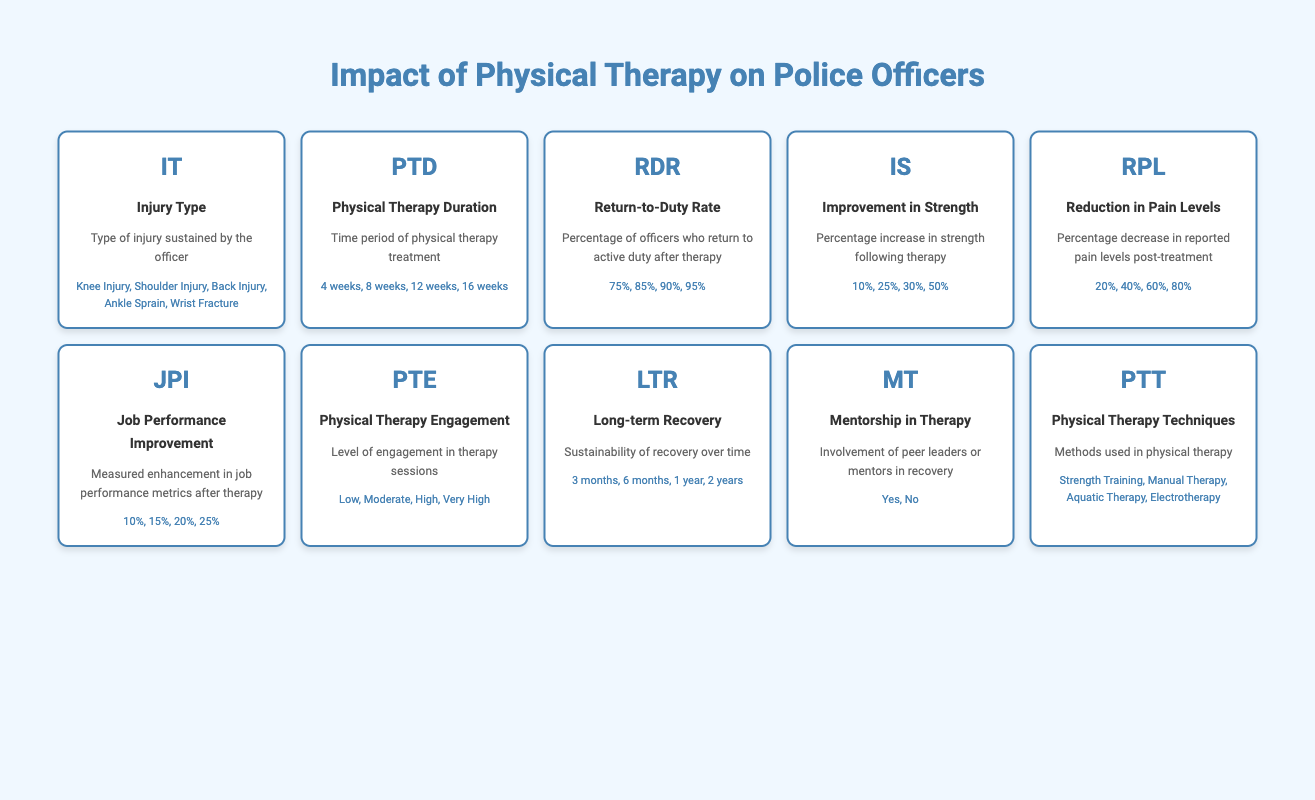What are some examples of injury types sustained by officers? The table lists several injury types under the "Injury Type" element. These examples include "Knee Injury," "Shoulder Injury," "Back Injury," "Ankle Sprain," and "Wrist Fracture."
Answer: Knee Injury, Shoulder Injury, Back Injury, Ankle Sprain, Wrist Fracture What is the longest duration of physical therapy listed? From the "Physical Therapy Duration" section in the table, the examples provided are "4 weeks," "8 weeks," "12 weeks," and "16 weeks." The longest duration is "16 weeks."
Answer: 16 weeks What is the average return-to-duty rate from the provided examples? The return-to-duty rates given in the table are "75%", "85%", "90%", and "95%." To find the average, add these percentages together: 75 + 85 + 90 + 95 = 345. There are four values, so the average is 345 / 4 = 86.25%.
Answer: 86.25% Is there an indication that mentorship in therapy is utilized? The table lists "Mentorship in Therapy" and provides examples, including "Yes" and "No." So it shows that mentorship can be present or absent, confirming that it does exist as an option in therapy sessions.
Answer: Yes What percentage improvement in strength is the highest noted in the examples? Under the "Improvement in Strength," the examples listed are "10%", "25%", "30%", and "50%." The highest percentage increase in strength is "50%."
Answer: 50% If an officer experiences a 40% reduction in pain and 20% job performance improvement, is it likely they engaged in high levels of physical therapy? The table shows levels of "Physical Therapy Engagement" ranging from "Low" to "Very High." Considering high engagement often correlates with improved outcomes, a 40% reduction in pain indicates efficacy, and 20% job performance improvement suggests beneficial therapy. Thus, high engagement is likely.
Answer: Probably yes How do the effects of therapy duration on strength improvement differ between 4 weeks and 16 weeks? The table does not provide explicit data comparing strength improvements between different therapy durations. However, typically longer therapy periods are associated with greater strength gains. By estimating based on data, we can infer that the 16-week duration likely yields significantly greater improvement in strength than a 4-week period.
Answer: 16 weeks likely yields greater improvement than 4 weeks What is the least percentage decrease in pain levels noted in the examples? The examples for "Reduction in Pain Levels" include "20%", "40%", "60%", and "80%." The least percentage decrease mentioned is "20%."
Answer: 20% What percentage of officers returning to duty is associated with very high physical therapy engagement? The table does not provide specific percentages linking return-to-duty rates with engagement levels directly. However, typically, higher engagement in therapy is expected to correlate with higher return-to-duty rates, which are represented by percentages ranging from "75%" to "95%."
Answer: Not explicitly stated, dependent on engagement 